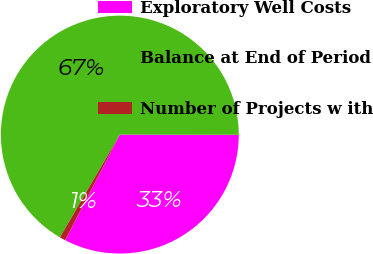Convert chart. <chart><loc_0><loc_0><loc_500><loc_500><pie_chart><fcel>Exploratory Well Costs<fcel>Balance at End of Period<fcel>Number of Projects w ith<nl><fcel>32.58%<fcel>66.62%<fcel>0.8%<nl></chart> 